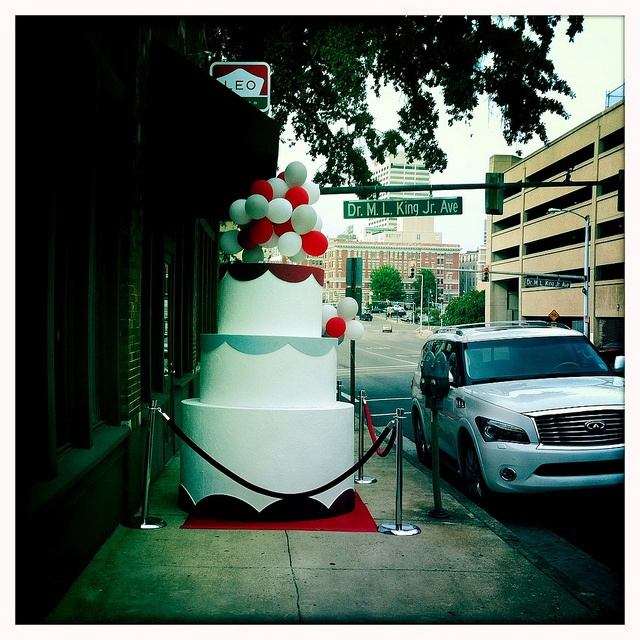Describe the objects in this image and their specific colors. I can see cake in white, lightgray, lightblue, black, and turquoise tones, car in white, black, teal, and lightblue tones, parking meter in white, black, and teal tones, parking meter in white, black, teal, and darkgreen tones, and car in white, beige, darkgray, and black tones in this image. 